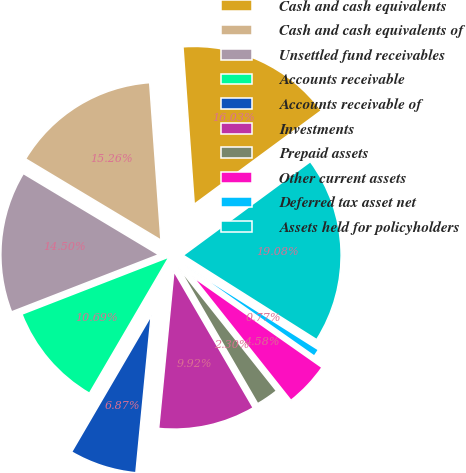Convert chart to OTSL. <chart><loc_0><loc_0><loc_500><loc_500><pie_chart><fcel>Cash and cash equivalents<fcel>Cash and cash equivalents of<fcel>Unsettled fund receivables<fcel>Accounts receivable<fcel>Accounts receivable of<fcel>Investments<fcel>Prepaid assets<fcel>Other current assets<fcel>Deferred tax asset net<fcel>Assets held for policyholders<nl><fcel>16.03%<fcel>15.26%<fcel>14.5%<fcel>10.69%<fcel>6.87%<fcel>9.92%<fcel>2.3%<fcel>4.58%<fcel>0.77%<fcel>19.08%<nl></chart> 